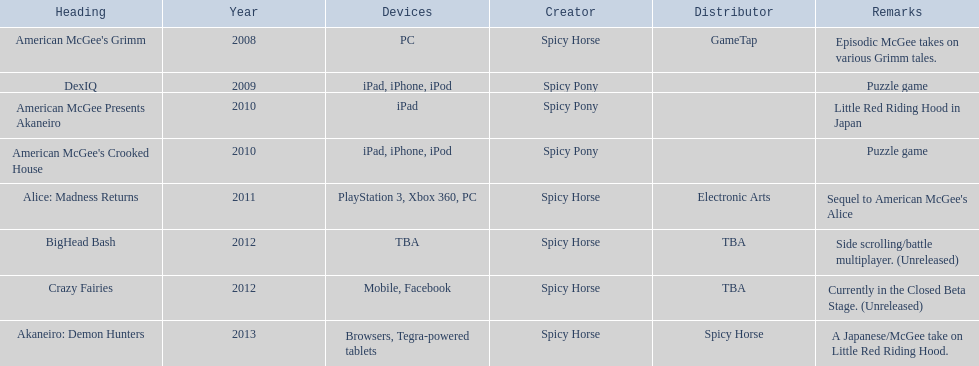What is the primary label on this chart? American McGee's Grimm. 